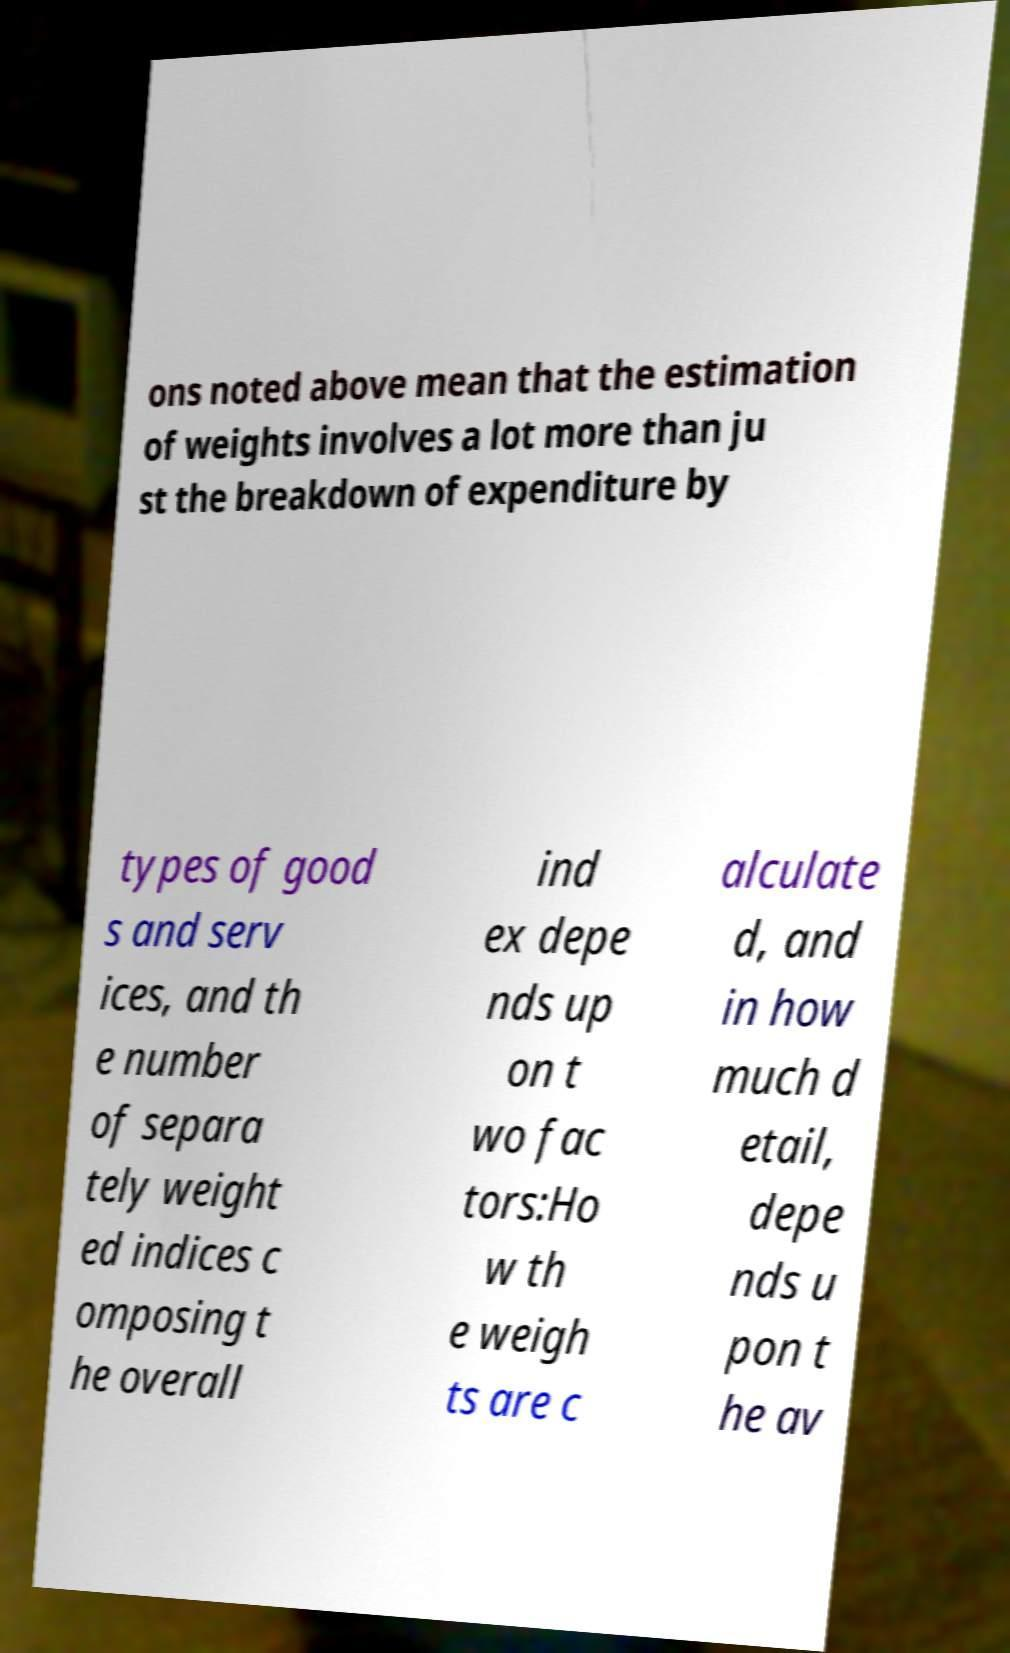Please read and relay the text visible in this image. What does it say? ons noted above mean that the estimation of weights involves a lot more than ju st the breakdown of expenditure by types of good s and serv ices, and th e number of separa tely weight ed indices c omposing t he overall ind ex depe nds up on t wo fac tors:Ho w th e weigh ts are c alculate d, and in how much d etail, depe nds u pon t he av 